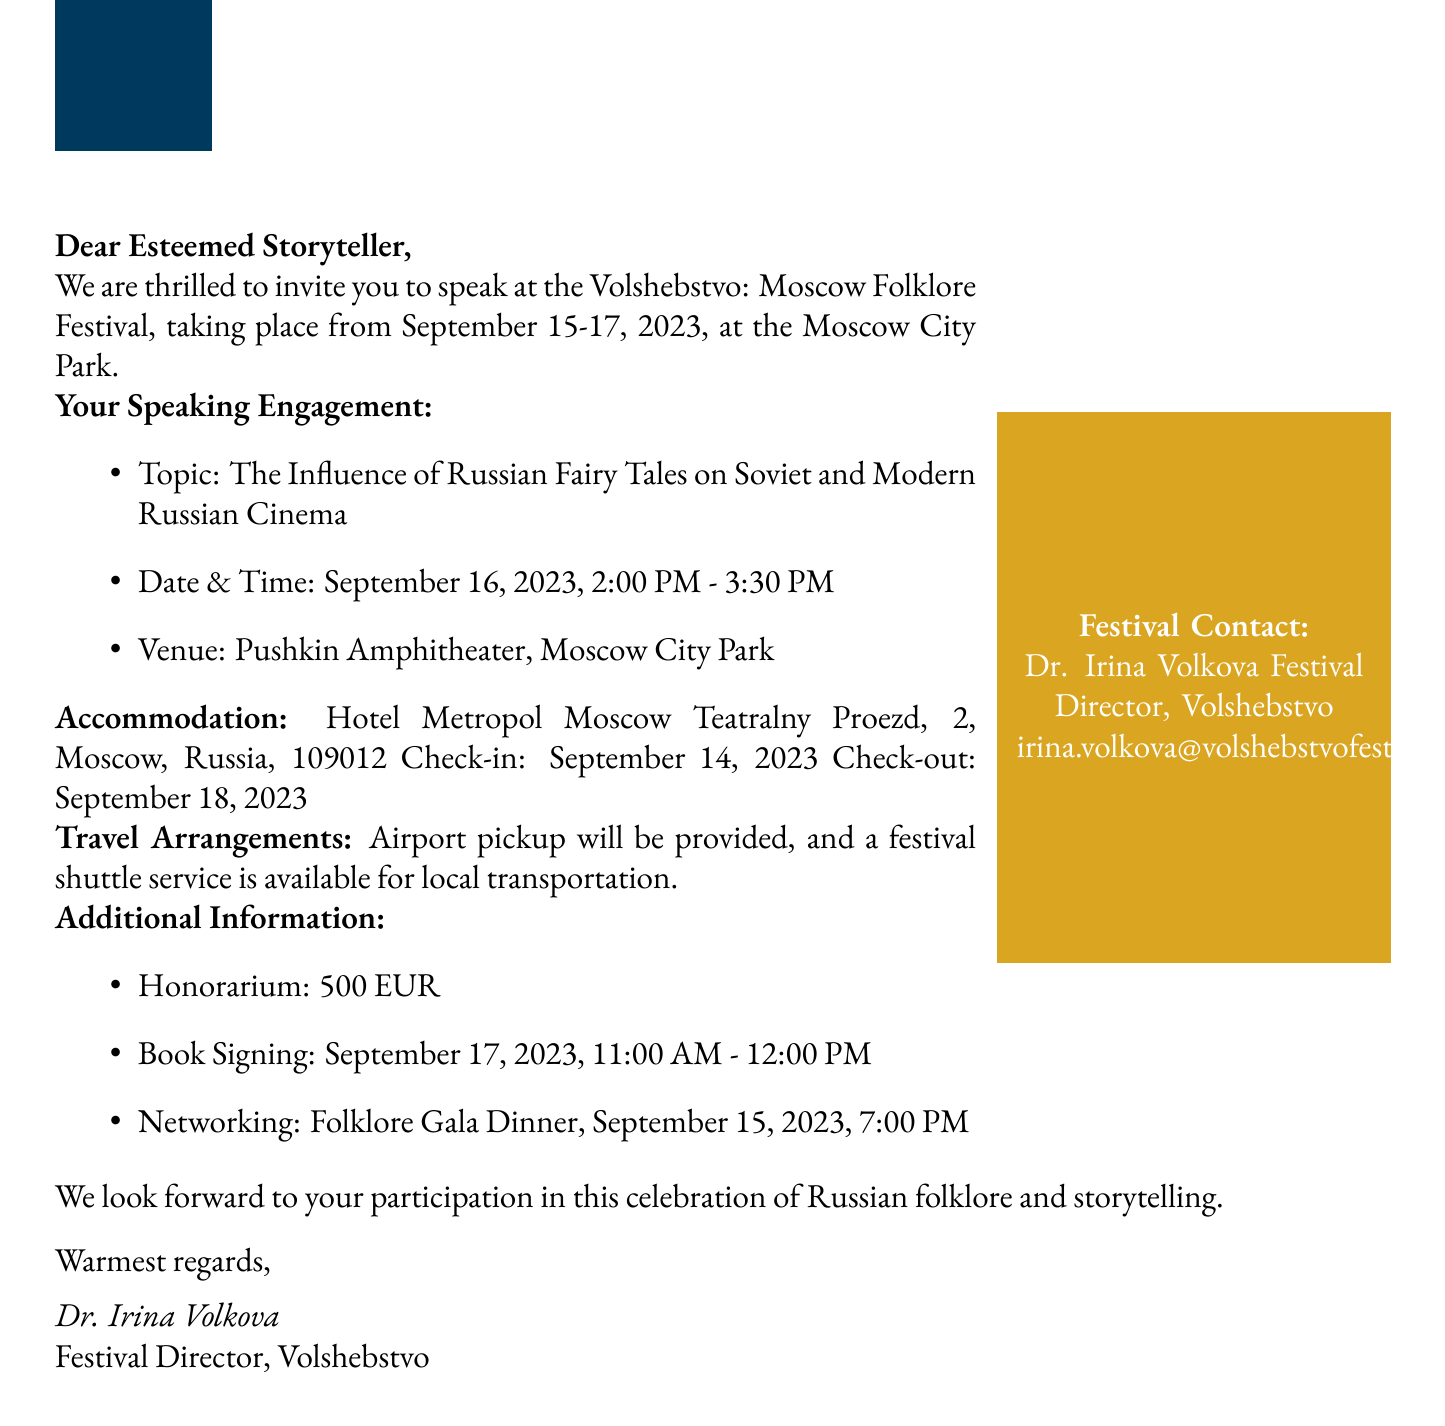What is the event name? The event name is specified in the title of the invitation.
Answer: Volshebstvo: Moscow Folklore Festival What are the festival dates? The festival dates are mentioned at the beginning of the invitation.
Answer: September 15-17, 2023 What is the speaking topic? The speaking topic is detailed in the section regarding the speaking engagement.
Answer: The Influence of Russian Fairy Tales on Soviet and Modern Russian Cinema Where will the speaking engagement take place? The venue for the speaking engagement is indicated under the speaking engagement details.
Answer: Pushkin Amphitheater, Moscow City Park Who is the festival director? The name of the festival director is mentioned in the contact details section.
Answer: Dr. Irina Volkova What is the check-in date for accommodation? The check-in date for accommodation is provided in the accommodation details section.
Answer: September 14, 2023 What is the honorarium amount? The honorarium is specified as additional information in the invitation.
Answer: 500 EUR When is the book signing opportunity? The book signing opportunity is listed under additional information.
Answer: September 17, 2023, 11:00 AM - 12:00 PM Is there local transportation available? The availability of local transportation is mentioned in the travel arrangements section.
Answer: Festival shuttle service available 